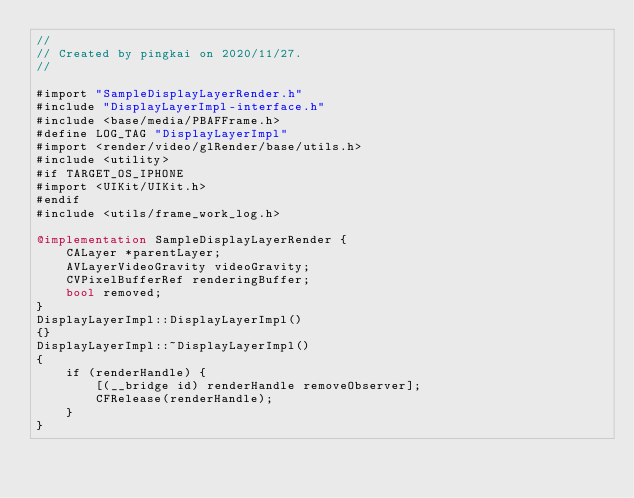Convert code to text. <code><loc_0><loc_0><loc_500><loc_500><_ObjectiveC_>//
// Created by pingkai on 2020/11/27.
//

#import "SampleDisplayLayerRender.h"
#include "DisplayLayerImpl-interface.h"
#include <base/media/PBAFFrame.h>
#define LOG_TAG "DisplayLayerImpl"
#import <render/video/glRender/base/utils.h>
#include <utility>
#if TARGET_OS_IPHONE
#import <UIKit/UIKit.h>
#endif
#include <utils/frame_work_log.h>

@implementation SampleDisplayLayerRender {
    CALayer *parentLayer;
    AVLayerVideoGravity videoGravity;
    CVPixelBufferRef renderingBuffer;
    bool removed;
}
DisplayLayerImpl::DisplayLayerImpl()
{}
DisplayLayerImpl::~DisplayLayerImpl()
{
    if (renderHandle) {
        [(__bridge id) renderHandle removeObserver];
        CFRelease(renderHandle);
    }
}</code> 